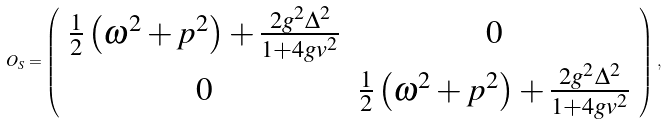Convert formula to latex. <formula><loc_0><loc_0><loc_500><loc_500>O _ { S } = \left ( \begin{array} { c c } \frac { 1 } { 2 } \left ( \omega ^ { 2 } + p ^ { 2 } \right ) + \frac { 2 g ^ { 2 } \Delta ^ { 2 } } { 1 + 4 g v ^ { 2 } } & 0 \\ 0 & \frac { 1 } { 2 } \left ( \omega ^ { 2 } + p ^ { 2 } \right ) + \frac { 2 g ^ { 2 } \Delta ^ { 2 } } { 1 + 4 g v ^ { 2 } } \\ \end{array} \right ) \, ,</formula> 